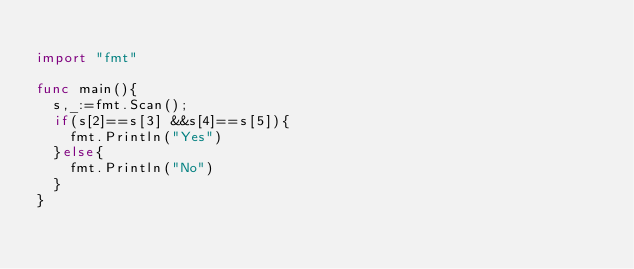Convert code to text. <code><loc_0><loc_0><loc_500><loc_500><_Go_> 
import "fmt"
 
func main(){
  s,_:=fmt.Scan();
  if(s[2]==s[3] &&s[4]==s[5]){
    fmt.Println("Yes")
  }else{
    fmt.Println("No")
  }
}</code> 